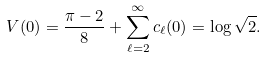Convert formula to latex. <formula><loc_0><loc_0><loc_500><loc_500>V ( 0 ) = \frac { \pi - 2 } { 8 } + \sum _ { \ell = 2 } ^ { \infty } c _ { \ell } ( 0 ) = \log \sqrt { 2 } .</formula> 